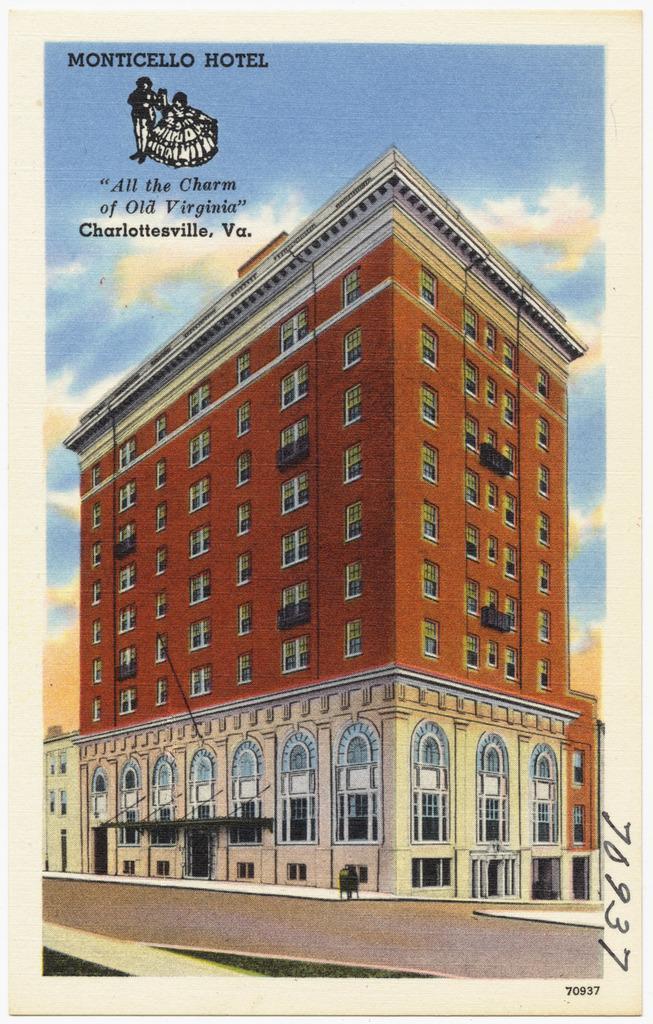Describe this image in one or two sentences. In this image we can see the picture of buildings and sky with clouds on the paper. 